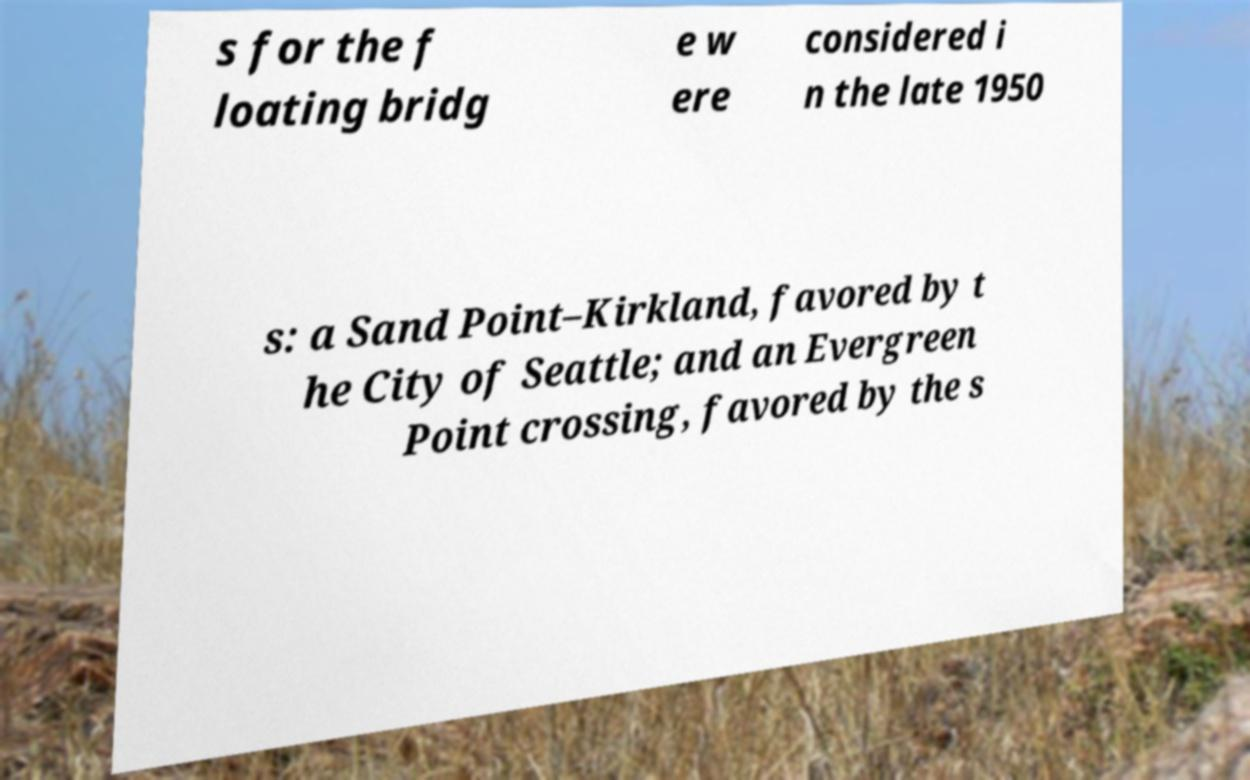Could you extract and type out the text from this image? s for the f loating bridg e w ere considered i n the late 1950 s: a Sand Point–Kirkland, favored by t he City of Seattle; and an Evergreen Point crossing, favored by the s 